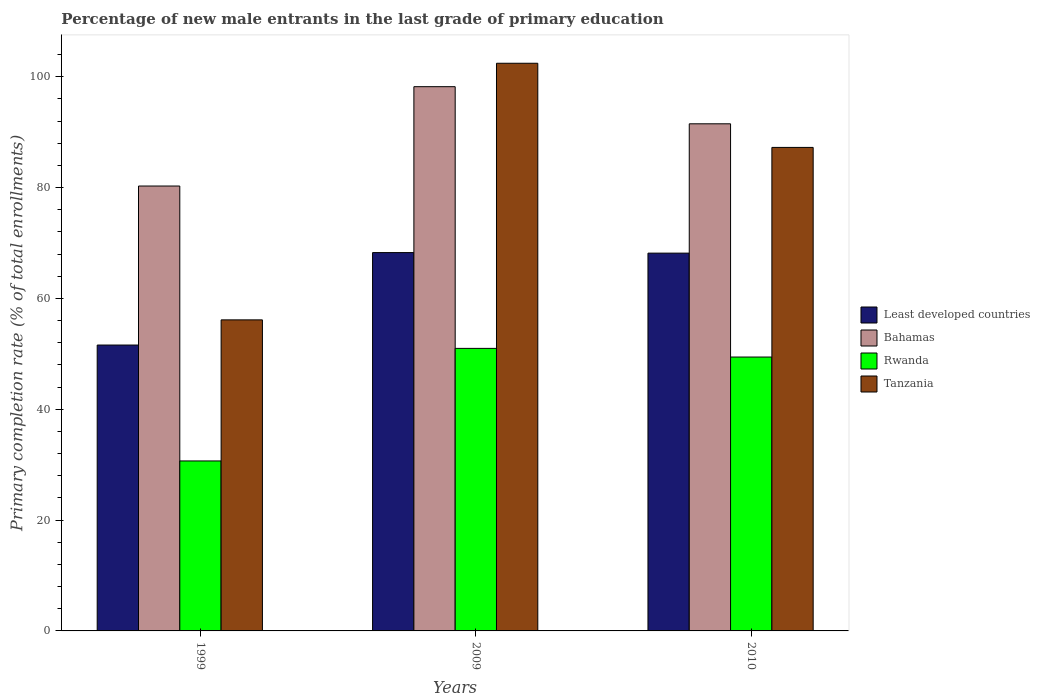Are the number of bars per tick equal to the number of legend labels?
Provide a short and direct response. Yes. What is the percentage of new male entrants in Rwanda in 2010?
Offer a very short reply. 49.43. Across all years, what is the maximum percentage of new male entrants in Bahamas?
Your response must be concise. 98.22. Across all years, what is the minimum percentage of new male entrants in Least developed countries?
Your answer should be very brief. 51.6. In which year was the percentage of new male entrants in Tanzania minimum?
Keep it short and to the point. 1999. What is the total percentage of new male entrants in Bahamas in the graph?
Make the answer very short. 270.03. What is the difference between the percentage of new male entrants in Least developed countries in 1999 and that in 2009?
Ensure brevity in your answer.  -16.68. What is the difference between the percentage of new male entrants in Least developed countries in 2010 and the percentage of new male entrants in Tanzania in 1999?
Your response must be concise. 12.04. What is the average percentage of new male entrants in Bahamas per year?
Keep it short and to the point. 90.01. In the year 1999, what is the difference between the percentage of new male entrants in Bahamas and percentage of new male entrants in Tanzania?
Your answer should be compact. 24.15. What is the ratio of the percentage of new male entrants in Bahamas in 1999 to that in 2010?
Offer a terse response. 0.88. Is the percentage of new male entrants in Least developed countries in 1999 less than that in 2009?
Provide a succinct answer. Yes. Is the difference between the percentage of new male entrants in Bahamas in 1999 and 2010 greater than the difference between the percentage of new male entrants in Tanzania in 1999 and 2010?
Your answer should be compact. Yes. What is the difference between the highest and the second highest percentage of new male entrants in Tanzania?
Make the answer very short. 15.19. What is the difference between the highest and the lowest percentage of new male entrants in Bahamas?
Provide a succinct answer. 17.93. Is the sum of the percentage of new male entrants in Tanzania in 1999 and 2010 greater than the maximum percentage of new male entrants in Bahamas across all years?
Provide a short and direct response. Yes. Is it the case that in every year, the sum of the percentage of new male entrants in Tanzania and percentage of new male entrants in Rwanda is greater than the sum of percentage of new male entrants in Least developed countries and percentage of new male entrants in Bahamas?
Offer a terse response. No. What does the 1st bar from the left in 2009 represents?
Your answer should be compact. Least developed countries. What does the 4th bar from the right in 2009 represents?
Keep it short and to the point. Least developed countries. Is it the case that in every year, the sum of the percentage of new male entrants in Tanzania and percentage of new male entrants in Least developed countries is greater than the percentage of new male entrants in Bahamas?
Provide a succinct answer. Yes. How many bars are there?
Give a very brief answer. 12. How many years are there in the graph?
Your answer should be compact. 3. Are the values on the major ticks of Y-axis written in scientific E-notation?
Your response must be concise. No. Does the graph contain any zero values?
Provide a succinct answer. No. Does the graph contain grids?
Give a very brief answer. No. How many legend labels are there?
Your answer should be compact. 4. What is the title of the graph?
Your response must be concise. Percentage of new male entrants in the last grade of primary education. What is the label or title of the X-axis?
Give a very brief answer. Years. What is the label or title of the Y-axis?
Give a very brief answer. Primary completion rate (% of total enrollments). What is the Primary completion rate (% of total enrollments) of Least developed countries in 1999?
Keep it short and to the point. 51.6. What is the Primary completion rate (% of total enrollments) in Bahamas in 1999?
Your response must be concise. 80.29. What is the Primary completion rate (% of total enrollments) in Rwanda in 1999?
Provide a succinct answer. 30.68. What is the Primary completion rate (% of total enrollments) of Tanzania in 1999?
Ensure brevity in your answer.  56.14. What is the Primary completion rate (% of total enrollments) of Least developed countries in 2009?
Ensure brevity in your answer.  68.28. What is the Primary completion rate (% of total enrollments) in Bahamas in 2009?
Offer a very short reply. 98.22. What is the Primary completion rate (% of total enrollments) in Rwanda in 2009?
Your response must be concise. 50.99. What is the Primary completion rate (% of total enrollments) in Tanzania in 2009?
Keep it short and to the point. 102.45. What is the Primary completion rate (% of total enrollments) in Least developed countries in 2010?
Provide a short and direct response. 68.18. What is the Primary completion rate (% of total enrollments) of Bahamas in 2010?
Offer a terse response. 91.52. What is the Primary completion rate (% of total enrollments) of Rwanda in 2010?
Make the answer very short. 49.43. What is the Primary completion rate (% of total enrollments) of Tanzania in 2010?
Your answer should be compact. 87.26. Across all years, what is the maximum Primary completion rate (% of total enrollments) in Least developed countries?
Give a very brief answer. 68.28. Across all years, what is the maximum Primary completion rate (% of total enrollments) of Bahamas?
Ensure brevity in your answer.  98.22. Across all years, what is the maximum Primary completion rate (% of total enrollments) of Rwanda?
Make the answer very short. 50.99. Across all years, what is the maximum Primary completion rate (% of total enrollments) of Tanzania?
Offer a very short reply. 102.45. Across all years, what is the minimum Primary completion rate (% of total enrollments) of Least developed countries?
Your answer should be very brief. 51.6. Across all years, what is the minimum Primary completion rate (% of total enrollments) of Bahamas?
Offer a very short reply. 80.29. Across all years, what is the minimum Primary completion rate (% of total enrollments) of Rwanda?
Provide a succinct answer. 30.68. Across all years, what is the minimum Primary completion rate (% of total enrollments) in Tanzania?
Provide a succinct answer. 56.14. What is the total Primary completion rate (% of total enrollments) in Least developed countries in the graph?
Your answer should be very brief. 188.05. What is the total Primary completion rate (% of total enrollments) of Bahamas in the graph?
Offer a very short reply. 270.03. What is the total Primary completion rate (% of total enrollments) in Rwanda in the graph?
Offer a terse response. 131.1. What is the total Primary completion rate (% of total enrollments) of Tanzania in the graph?
Keep it short and to the point. 245.85. What is the difference between the Primary completion rate (% of total enrollments) of Least developed countries in 1999 and that in 2009?
Give a very brief answer. -16.68. What is the difference between the Primary completion rate (% of total enrollments) of Bahamas in 1999 and that in 2009?
Keep it short and to the point. -17.93. What is the difference between the Primary completion rate (% of total enrollments) in Rwanda in 1999 and that in 2009?
Your answer should be very brief. -20.31. What is the difference between the Primary completion rate (% of total enrollments) in Tanzania in 1999 and that in 2009?
Keep it short and to the point. -46.31. What is the difference between the Primary completion rate (% of total enrollments) in Least developed countries in 1999 and that in 2010?
Keep it short and to the point. -16.58. What is the difference between the Primary completion rate (% of total enrollments) of Bahamas in 1999 and that in 2010?
Provide a succinct answer. -11.23. What is the difference between the Primary completion rate (% of total enrollments) in Rwanda in 1999 and that in 2010?
Offer a very short reply. -18.75. What is the difference between the Primary completion rate (% of total enrollments) in Tanzania in 1999 and that in 2010?
Your response must be concise. -31.12. What is the difference between the Primary completion rate (% of total enrollments) in Least developed countries in 2009 and that in 2010?
Offer a very short reply. 0.1. What is the difference between the Primary completion rate (% of total enrollments) in Bahamas in 2009 and that in 2010?
Provide a short and direct response. 6.7. What is the difference between the Primary completion rate (% of total enrollments) in Rwanda in 2009 and that in 2010?
Give a very brief answer. 1.56. What is the difference between the Primary completion rate (% of total enrollments) of Tanzania in 2009 and that in 2010?
Your response must be concise. 15.19. What is the difference between the Primary completion rate (% of total enrollments) in Least developed countries in 1999 and the Primary completion rate (% of total enrollments) in Bahamas in 2009?
Provide a short and direct response. -46.63. What is the difference between the Primary completion rate (% of total enrollments) of Least developed countries in 1999 and the Primary completion rate (% of total enrollments) of Rwanda in 2009?
Give a very brief answer. 0.6. What is the difference between the Primary completion rate (% of total enrollments) in Least developed countries in 1999 and the Primary completion rate (% of total enrollments) in Tanzania in 2009?
Offer a terse response. -50.85. What is the difference between the Primary completion rate (% of total enrollments) of Bahamas in 1999 and the Primary completion rate (% of total enrollments) of Rwanda in 2009?
Provide a short and direct response. 29.3. What is the difference between the Primary completion rate (% of total enrollments) of Bahamas in 1999 and the Primary completion rate (% of total enrollments) of Tanzania in 2009?
Your answer should be very brief. -22.16. What is the difference between the Primary completion rate (% of total enrollments) in Rwanda in 1999 and the Primary completion rate (% of total enrollments) in Tanzania in 2009?
Keep it short and to the point. -71.77. What is the difference between the Primary completion rate (% of total enrollments) of Least developed countries in 1999 and the Primary completion rate (% of total enrollments) of Bahamas in 2010?
Provide a short and direct response. -39.93. What is the difference between the Primary completion rate (% of total enrollments) in Least developed countries in 1999 and the Primary completion rate (% of total enrollments) in Rwanda in 2010?
Provide a short and direct response. 2.17. What is the difference between the Primary completion rate (% of total enrollments) in Least developed countries in 1999 and the Primary completion rate (% of total enrollments) in Tanzania in 2010?
Keep it short and to the point. -35.67. What is the difference between the Primary completion rate (% of total enrollments) in Bahamas in 1999 and the Primary completion rate (% of total enrollments) in Rwanda in 2010?
Offer a very short reply. 30.86. What is the difference between the Primary completion rate (% of total enrollments) in Bahamas in 1999 and the Primary completion rate (% of total enrollments) in Tanzania in 2010?
Offer a terse response. -6.97. What is the difference between the Primary completion rate (% of total enrollments) of Rwanda in 1999 and the Primary completion rate (% of total enrollments) of Tanzania in 2010?
Offer a very short reply. -56.58. What is the difference between the Primary completion rate (% of total enrollments) of Least developed countries in 2009 and the Primary completion rate (% of total enrollments) of Bahamas in 2010?
Your response must be concise. -23.24. What is the difference between the Primary completion rate (% of total enrollments) in Least developed countries in 2009 and the Primary completion rate (% of total enrollments) in Rwanda in 2010?
Ensure brevity in your answer.  18.85. What is the difference between the Primary completion rate (% of total enrollments) of Least developed countries in 2009 and the Primary completion rate (% of total enrollments) of Tanzania in 2010?
Provide a short and direct response. -18.98. What is the difference between the Primary completion rate (% of total enrollments) of Bahamas in 2009 and the Primary completion rate (% of total enrollments) of Rwanda in 2010?
Your response must be concise. 48.79. What is the difference between the Primary completion rate (% of total enrollments) in Bahamas in 2009 and the Primary completion rate (% of total enrollments) in Tanzania in 2010?
Offer a terse response. 10.96. What is the difference between the Primary completion rate (% of total enrollments) of Rwanda in 2009 and the Primary completion rate (% of total enrollments) of Tanzania in 2010?
Ensure brevity in your answer.  -36.27. What is the average Primary completion rate (% of total enrollments) in Least developed countries per year?
Give a very brief answer. 62.68. What is the average Primary completion rate (% of total enrollments) in Bahamas per year?
Ensure brevity in your answer.  90.01. What is the average Primary completion rate (% of total enrollments) in Rwanda per year?
Make the answer very short. 43.7. What is the average Primary completion rate (% of total enrollments) of Tanzania per year?
Make the answer very short. 81.95. In the year 1999, what is the difference between the Primary completion rate (% of total enrollments) in Least developed countries and Primary completion rate (% of total enrollments) in Bahamas?
Ensure brevity in your answer.  -28.7. In the year 1999, what is the difference between the Primary completion rate (% of total enrollments) of Least developed countries and Primary completion rate (% of total enrollments) of Rwanda?
Your answer should be very brief. 20.92. In the year 1999, what is the difference between the Primary completion rate (% of total enrollments) in Least developed countries and Primary completion rate (% of total enrollments) in Tanzania?
Keep it short and to the point. -4.54. In the year 1999, what is the difference between the Primary completion rate (% of total enrollments) of Bahamas and Primary completion rate (% of total enrollments) of Rwanda?
Provide a succinct answer. 49.61. In the year 1999, what is the difference between the Primary completion rate (% of total enrollments) in Bahamas and Primary completion rate (% of total enrollments) in Tanzania?
Offer a very short reply. 24.15. In the year 1999, what is the difference between the Primary completion rate (% of total enrollments) of Rwanda and Primary completion rate (% of total enrollments) of Tanzania?
Your answer should be compact. -25.46. In the year 2009, what is the difference between the Primary completion rate (% of total enrollments) of Least developed countries and Primary completion rate (% of total enrollments) of Bahamas?
Provide a succinct answer. -29.94. In the year 2009, what is the difference between the Primary completion rate (% of total enrollments) of Least developed countries and Primary completion rate (% of total enrollments) of Rwanda?
Offer a very short reply. 17.29. In the year 2009, what is the difference between the Primary completion rate (% of total enrollments) of Least developed countries and Primary completion rate (% of total enrollments) of Tanzania?
Your answer should be compact. -34.17. In the year 2009, what is the difference between the Primary completion rate (% of total enrollments) of Bahamas and Primary completion rate (% of total enrollments) of Rwanda?
Make the answer very short. 47.23. In the year 2009, what is the difference between the Primary completion rate (% of total enrollments) in Bahamas and Primary completion rate (% of total enrollments) in Tanzania?
Your response must be concise. -4.23. In the year 2009, what is the difference between the Primary completion rate (% of total enrollments) of Rwanda and Primary completion rate (% of total enrollments) of Tanzania?
Your response must be concise. -51.46. In the year 2010, what is the difference between the Primary completion rate (% of total enrollments) in Least developed countries and Primary completion rate (% of total enrollments) in Bahamas?
Offer a terse response. -23.34. In the year 2010, what is the difference between the Primary completion rate (% of total enrollments) of Least developed countries and Primary completion rate (% of total enrollments) of Rwanda?
Offer a very short reply. 18.75. In the year 2010, what is the difference between the Primary completion rate (% of total enrollments) in Least developed countries and Primary completion rate (% of total enrollments) in Tanzania?
Provide a succinct answer. -19.08. In the year 2010, what is the difference between the Primary completion rate (% of total enrollments) in Bahamas and Primary completion rate (% of total enrollments) in Rwanda?
Your answer should be very brief. 42.09. In the year 2010, what is the difference between the Primary completion rate (% of total enrollments) in Bahamas and Primary completion rate (% of total enrollments) in Tanzania?
Offer a terse response. 4.26. In the year 2010, what is the difference between the Primary completion rate (% of total enrollments) in Rwanda and Primary completion rate (% of total enrollments) in Tanzania?
Make the answer very short. -37.83. What is the ratio of the Primary completion rate (% of total enrollments) in Least developed countries in 1999 to that in 2009?
Your answer should be compact. 0.76. What is the ratio of the Primary completion rate (% of total enrollments) in Bahamas in 1999 to that in 2009?
Make the answer very short. 0.82. What is the ratio of the Primary completion rate (% of total enrollments) of Rwanda in 1999 to that in 2009?
Keep it short and to the point. 0.6. What is the ratio of the Primary completion rate (% of total enrollments) of Tanzania in 1999 to that in 2009?
Ensure brevity in your answer.  0.55. What is the ratio of the Primary completion rate (% of total enrollments) in Least developed countries in 1999 to that in 2010?
Provide a short and direct response. 0.76. What is the ratio of the Primary completion rate (% of total enrollments) of Bahamas in 1999 to that in 2010?
Provide a short and direct response. 0.88. What is the ratio of the Primary completion rate (% of total enrollments) of Rwanda in 1999 to that in 2010?
Your answer should be compact. 0.62. What is the ratio of the Primary completion rate (% of total enrollments) in Tanzania in 1999 to that in 2010?
Ensure brevity in your answer.  0.64. What is the ratio of the Primary completion rate (% of total enrollments) in Bahamas in 2009 to that in 2010?
Provide a short and direct response. 1.07. What is the ratio of the Primary completion rate (% of total enrollments) in Rwanda in 2009 to that in 2010?
Your response must be concise. 1.03. What is the ratio of the Primary completion rate (% of total enrollments) of Tanzania in 2009 to that in 2010?
Ensure brevity in your answer.  1.17. What is the difference between the highest and the second highest Primary completion rate (% of total enrollments) in Least developed countries?
Your answer should be compact. 0.1. What is the difference between the highest and the second highest Primary completion rate (% of total enrollments) of Bahamas?
Make the answer very short. 6.7. What is the difference between the highest and the second highest Primary completion rate (% of total enrollments) of Rwanda?
Your response must be concise. 1.56. What is the difference between the highest and the second highest Primary completion rate (% of total enrollments) of Tanzania?
Provide a short and direct response. 15.19. What is the difference between the highest and the lowest Primary completion rate (% of total enrollments) of Least developed countries?
Provide a succinct answer. 16.68. What is the difference between the highest and the lowest Primary completion rate (% of total enrollments) in Bahamas?
Provide a succinct answer. 17.93. What is the difference between the highest and the lowest Primary completion rate (% of total enrollments) of Rwanda?
Your answer should be very brief. 20.31. What is the difference between the highest and the lowest Primary completion rate (% of total enrollments) of Tanzania?
Offer a very short reply. 46.31. 